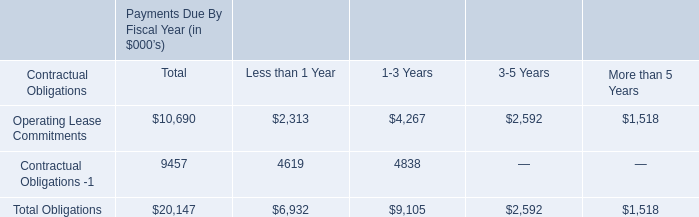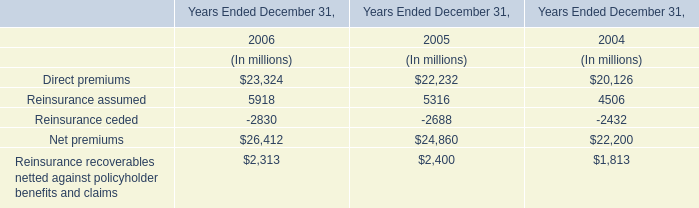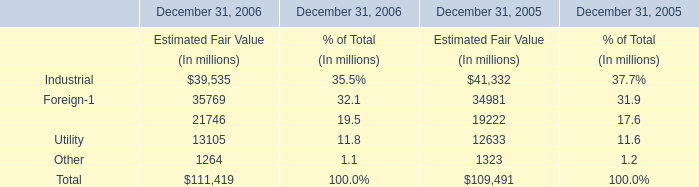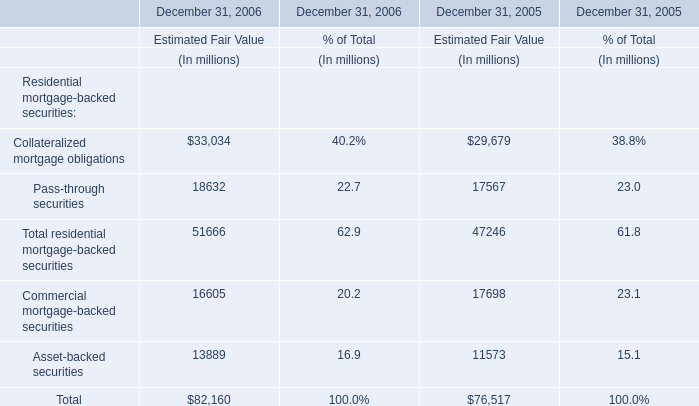What do all Residential mortgage-backed securities: sum up without those Residential mortgage-backed securities smaller than 20000, in 2006? (in million) 
Computations: ((33034 + 18632) + 51666)
Answer: 103332.0. 